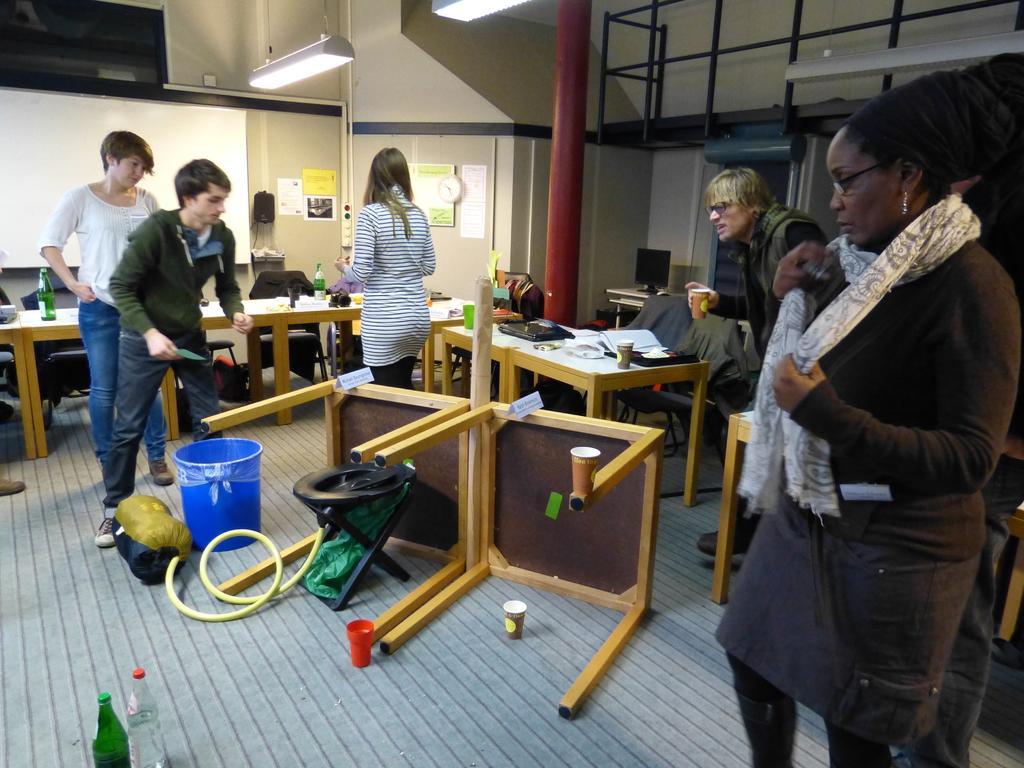How would you summarize this image in a sentence or two? In this image two persons standing on the right side of the image. first person ,is a woman wearing white color scarf and also wearing spectacles. another person stand back side the woman wearing blue color jeans pant. and the right corner there is a person holding a glass. on the left side there are the two persons standing first person wearing as green color t- shirt. second person is a woman wearing a white color shirt. and the middle of the image there is a person wearing a white color shirt. and on the middle of the image there is a table on the floor. And there is another table on the floor. And there are two glasses kept on the floor. And one glass kept on the table,and there is a blue color bucket on the floor. And there is a cylinder attached to the pipe. on the top most there is table,on the table there is a object kept on the table. on the right top there is a table. on the right top corner there is a system kept on the table. on the right top corner there is a pipe line. back side of the pipe line there is a wall. clock attached to the wall. 